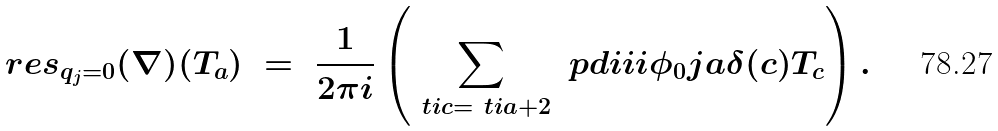<formula> <loc_0><loc_0><loc_500><loc_500>\ r e s _ { q _ { j } = 0 } ( \nabla ) ( T _ { a } ) \ = \ \frac { 1 } { 2 \pi i } \left ( \sum _ { \ t i { c } = \ t i { a } + 2 } \ p d i i i { \phi _ { 0 } } { j } { a } { \delta ( c ) } T _ { c } \right ) .</formula> 